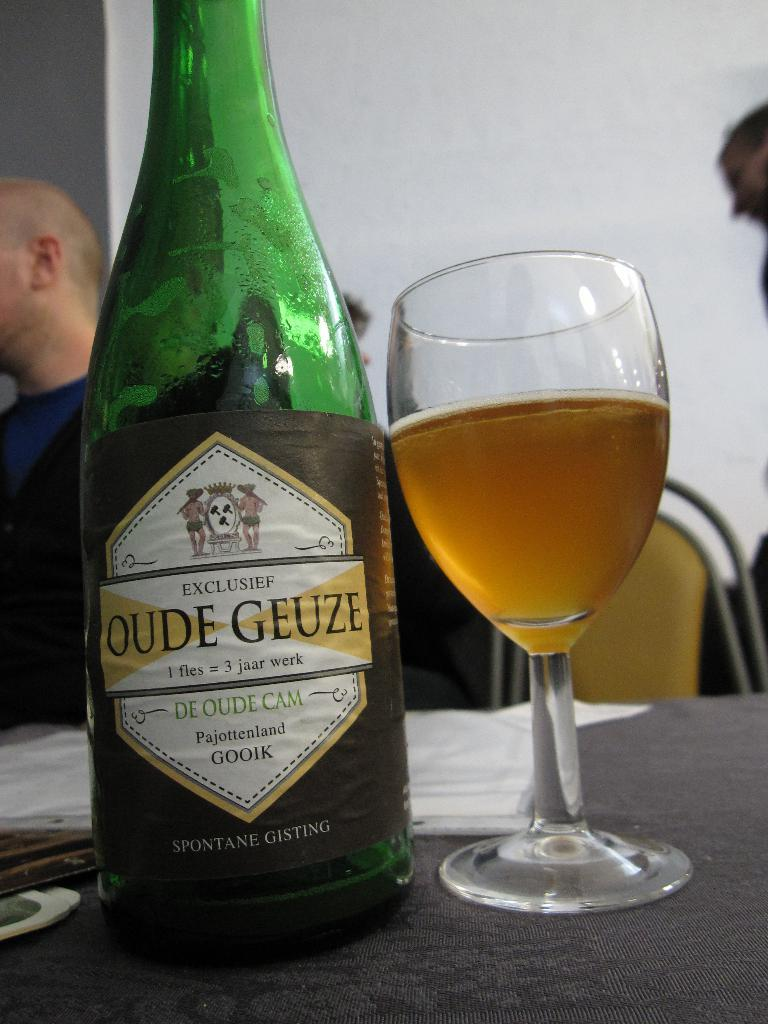Provide a one-sentence caption for the provided image. "OUDE GEUZE" is printed on the label of a bottle. 